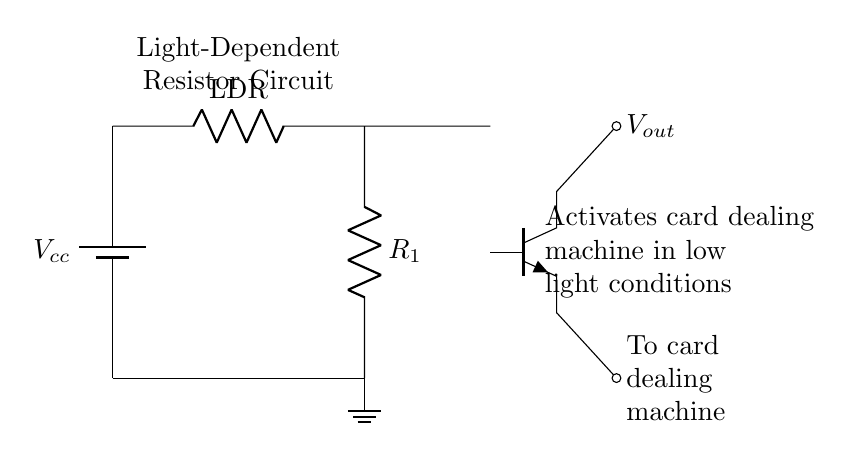What component is used to detect light? The light-dependent resistor, labeled as LDR, decreases resistance based on the amount of light present.
Answer: LDR What is the function of the transistor in this circuit? The transistor acts as a switch, allowing the card dealing machine to activate when the conditions from the LDR are met.
Answer: Switch What is the voltage source in this circuit? The voltage source is represented by the battery, indicated as Vcc, providing the necessary power for the circuit to operate.
Answer: Vcc How many resistors are present in the circuit? There are two resistors: one is the LDR and the other is a standard resistor labeled R1.
Answer: Two What happens to the circuit when light levels are low? The LDR's resistance increases, turning on the transistor, which activates the card dealing machine.
Answer: Activates machine What type of transistor is used in this circuit? The circuit uses an NPN transistor, as indicated by the symbol in the diagram.
Answer: NPN What is the output voltage from the transistor? The output voltage from the transistor is labeled as Vout, indicating the voltage supplied to the card dealing machine when activated.
Answer: Vout 